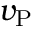Convert formula to latex. <formula><loc_0><loc_0><loc_500><loc_500>v _ { P }</formula> 